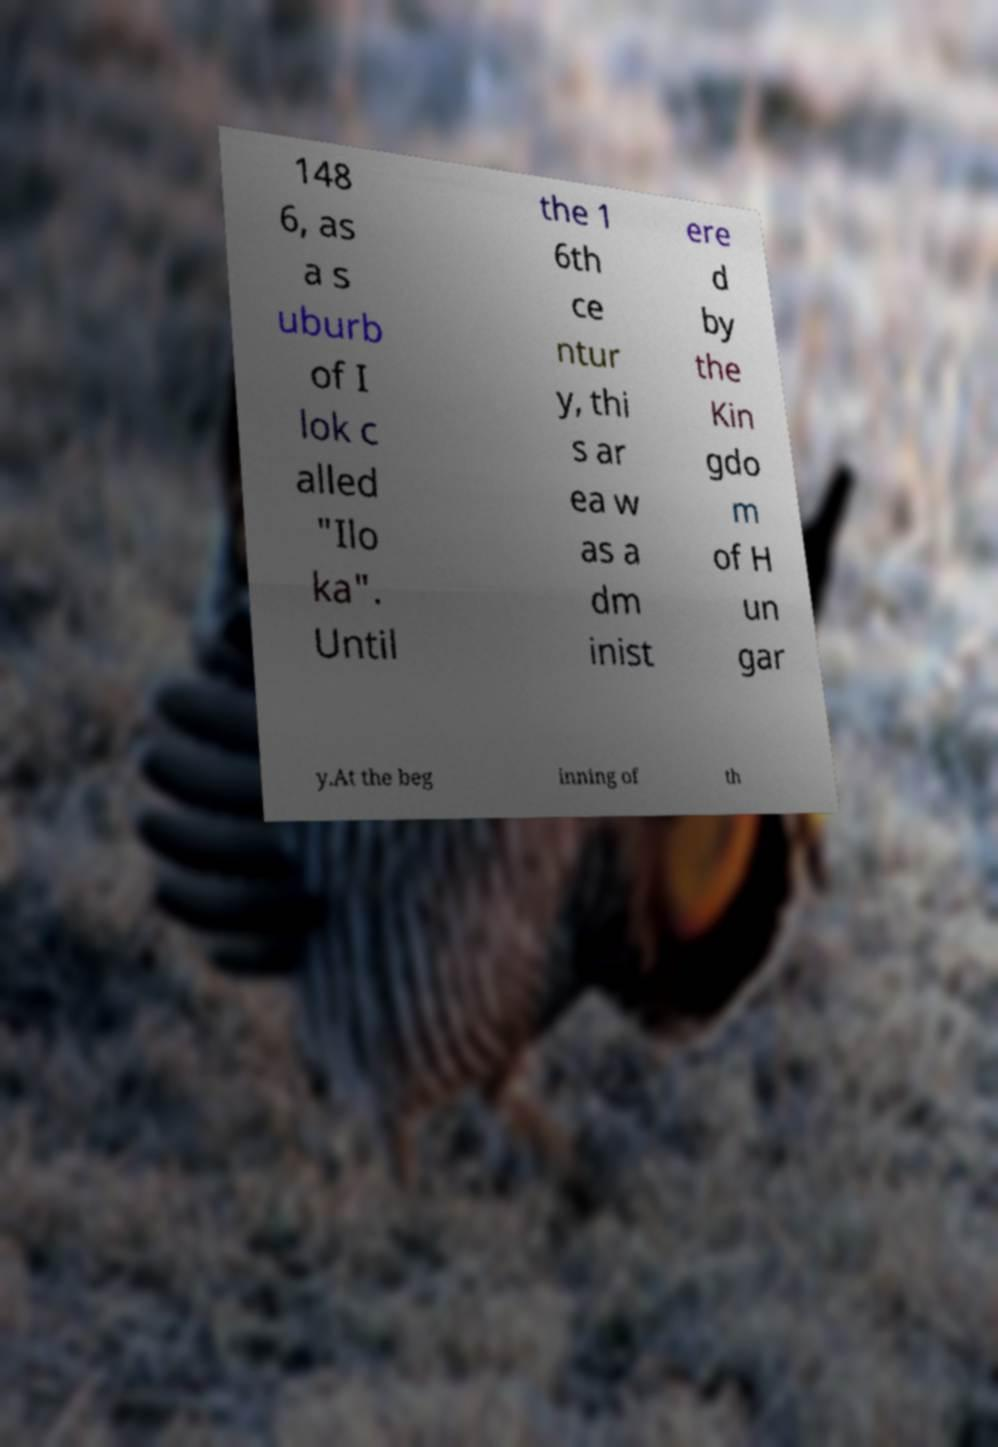I need the written content from this picture converted into text. Can you do that? 148 6, as a s uburb of I lok c alled "Ilo ka". Until the 1 6th ce ntur y, thi s ar ea w as a dm inist ere d by the Kin gdo m of H un gar y.At the beg inning of th 